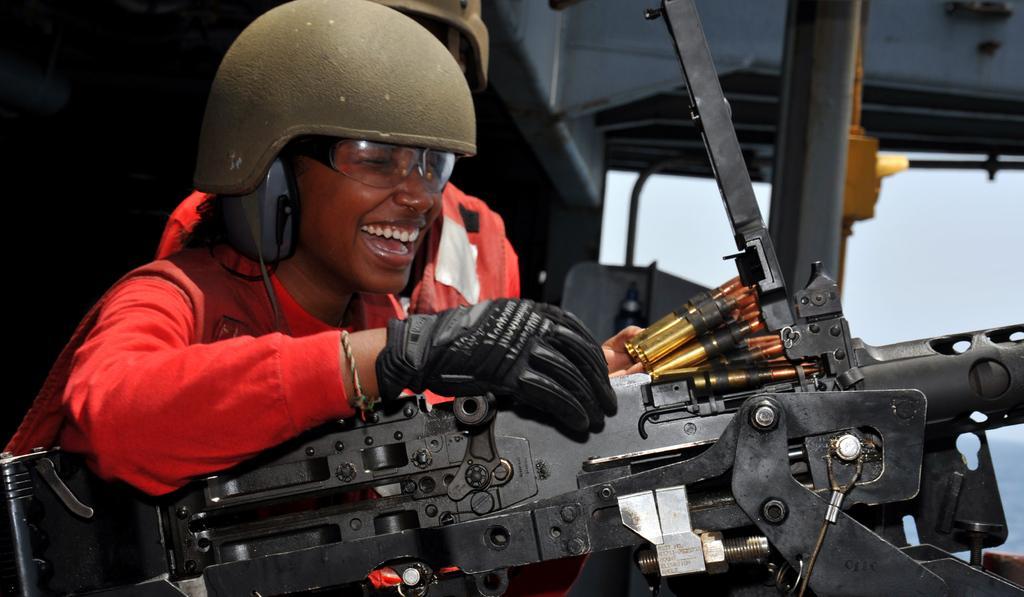Describe this image in one or two sentences. This image is taken in a vehicle. On the right side of the image there is a window and through the window we can see the sky. In the middle of the image a person is sitting in the vehicle and holding a few bullets in hand. At the bottom of the image there is an iron weapon. The person has worn a helmet, goggles and gloves. At the top of the image there is a roof. 